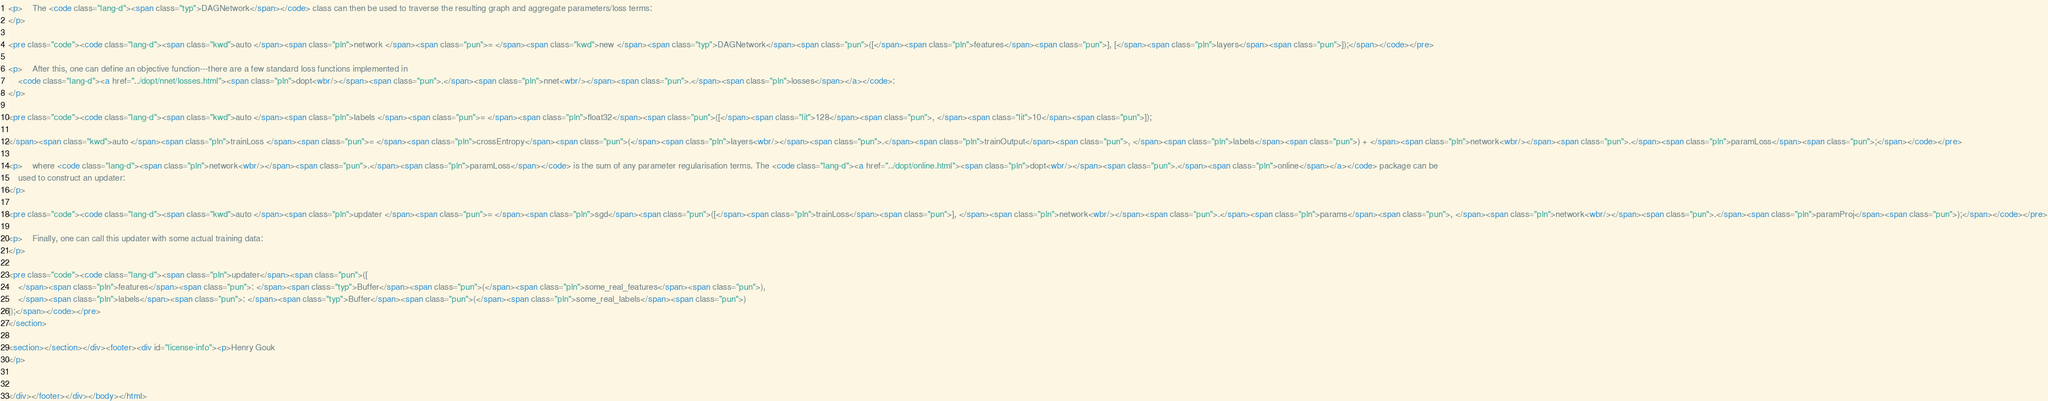<code> <loc_0><loc_0><loc_500><loc_500><_HTML_><p>    The <code class="lang-d"><span class="typ">DAGNetwork</span></code> class can then be used to traverse the resulting graph and aggregate parameters/loss terms:
</p>

<pre class="code"><code class="lang-d"><span class="kwd">auto </span><span class="pln">network </span><span class="pun">= </span><span class="kwd">new </span><span class="typ">DAGNetwork</span><span class="pun">([</span><span class="pln">features</span><span class="pun">], [</span><span class="pln">layers</span><span class="pun">]);</span></code></pre>

<p>    After this, one can define an objective function---there are a few standard loss functions implemented in
    <code class="lang-d"><a href="../dopt/nnet/losses.html"><span class="pln">dopt<wbr/></span><span class="pun">.</span><span class="pln">nnet<wbr/></span><span class="pun">.</span><span class="pln">losses</span></a></code>:
</p>

<pre class="code"><code class="lang-d"><span class="kwd">auto </span><span class="pln">labels </span><span class="pun">= </span><span class="pln">float32</span><span class="pun">([</span><span class="lit">128</span><span class="pun">, </span><span class="lit">10</span><span class="pun">]);

</span><span class="kwd">auto </span><span class="pln">trainLoss </span><span class="pun">= </span><span class="pln">crossEntropy</span><span class="pun">(</span><span class="pln">layers<wbr/></span><span class="pun">.</span><span class="pln">trainOutput</span><span class="pun">, </span><span class="pln">labels</span><span class="pun">) + </span><span class="pln">network<wbr/></span><span class="pun">.</span><span class="pln">paramLoss</span><span class="pun">;</span></code></pre>

<p>    where <code class="lang-d"><span class="pln">network<wbr/></span><span class="pun">.</span><span class="pln">paramLoss</span></code> is the sum of any parameter regularisation terms. The <code class="lang-d"><a href="../dopt/online.html"><span class="pln">dopt<wbr/></span><span class="pun">.</span><span class="pln">online</span></a></code> package can be
    used to construct an updater:
</p>

<pre class="code"><code class="lang-d"><span class="kwd">auto </span><span class="pln">updater </span><span class="pun">= </span><span class="pln">sgd</span><span class="pun">([</span><span class="pln">trainLoss</span><span class="pun">], </span><span class="pln">network<wbr/></span><span class="pun">.</span><span class="pln">params</span><span class="pun">, </span><span class="pln">network<wbr/></span><span class="pun">.</span><span class="pln">paramProj</span><span class="pun">);</span></code></pre>

<p>    Finally, one can call this updater with some actual training data:
</p>

<pre class="code"><code class="lang-d"><span class="pln">updater</span><span class="pun">([
    </span><span class="pln">features</span><span class="pun">: </span><span class="typ">Buffer</span><span class="pun">(</span><span class="pln">some_real_features</span><span class="pun">),
    </span><span class="pln">labels</span><span class="pun">: </span><span class="typ">Buffer</span><span class="pun">(</span><span class="pln">some_real_labels</span><span class="pun">)
]);</span></code></pre>
</section>

<section></section></div><footer><div id="license-info"><p>Henry Gouk
</p>


</div></footer></div></body></html></code> 